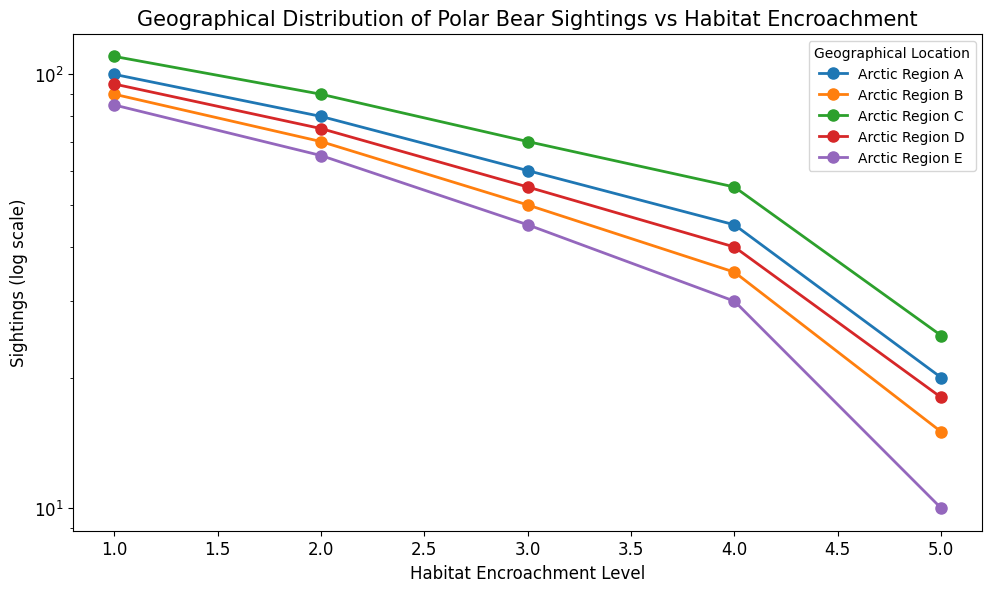What is the general trend of polar bear sightings as habitat encroachment level increases? All geographical locations show a decreasing trend in polar bear sightings as habitat encroachment level increases. Polar bear sightings are highest at Habitat Encroachment Level 1 and decrease steadily with each higher level of encroachment.
Answer: Decreasing trend Which geographical location has the highest number of sightings at Habitat Encroachment Level 3? By examining the heights of the lines at Habitat Encroachment Level 3, Arctic Region C has the highest point with 70 sightings, followed by Arctic Region A, B, D, and E.
Answer: Arctic Region C What is the difference in the number of sightings between the highest and lowest geographical locations at Habitat Encroachment Level 5? The highest number of sightings at Level 5 is in Arctic Region C with 25 sightings, and the lowest is in Arctic Region E with 10 sightings. The difference is 25 - 10 = 15 sightings.
Answer: 15 Compare the number of sightings at Habitat Encroachment Level 2 between Arctic Region A and Arctic Region D. Examining the figure, Arctic Region A has 80 sightings at Level 2, while Arctic Region D has 75 sightings. Arctic Region A has 5 more sightings than Arctic Region D.
Answer: 80 vs. 75 Which geographic locations have the closest number of sightings at Habitat Encroachment Level 4? At Habitat Encroachment Level 4, Arctic Region A (45 sightings) and Arctic Region C (55 sightings) are close in count to Arctic Region D (40 sightings). The closest pair is Arctic Region A and Arctic Region D, with a difference of 5 sightings.
Answer: Arctic Region A and D What is the total number of polar bear sightings across all geographical locations at Habitat Encroachment Level 1? Add the number of sightings at Level 1 across all regions: 100 (A) + 90 (B) + 110 (C) + 95 (D) + 85 (E) = 480 sightings.
Answer: 480 Which geographical location shows the most significant drop in sightings from Habitat Encroachment Level 1 to Level 5? Calculate the drop for each geographical location: 
- Arctic Region A: 100 - 20 = 80
- Arctic Region B: 90 - 15 = 75
- Arctic Region C: 110 - 25 = 85
- Arctic Region D: 95 - 18 = 77
- Arctic Region E: 85 - 10 = 75
The most significant drop is in Arctic Region C, with a drop of 85 sightings.
Answer: Arctic Region C What percentage decrease do we observe in sightings from Habitat Encroachment Level 1 to Level 5 in Arctic Region B? Calculate the percentage decrease: ((90 - 15) / 90) * 100 = (75 / 90) * 100 ≈ 83.33%.
Answer: ≈ 83.33% Which region has the least variation in polar bear sightings across all levels of habitat encroachment? Compare the range of sightings (maximum minus minimum) across all regions: 
- Arctic Region A: 100 - 20 = 80
- Arctic Region B: 90 - 15 = 75
- Arctic Region C: 110 - 25 = 85
- Arctic Region D: 95 - 18 = 77
- Arctic Region E: 85 - 10 = 75
The least variation is seen in Arctic Regions B and E, both with variations of 75 sightings.
Answer: Arctic Region B and E 